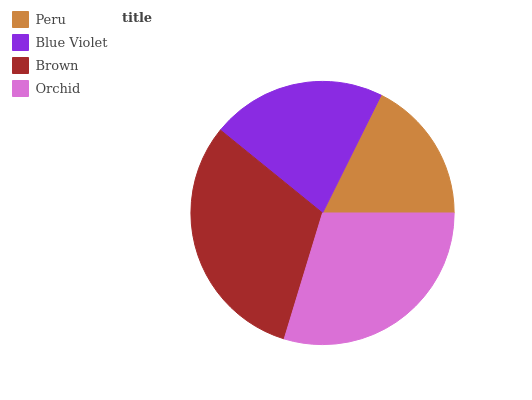Is Peru the minimum?
Answer yes or no. Yes. Is Brown the maximum?
Answer yes or no. Yes. Is Blue Violet the minimum?
Answer yes or no. No. Is Blue Violet the maximum?
Answer yes or no. No. Is Blue Violet greater than Peru?
Answer yes or no. Yes. Is Peru less than Blue Violet?
Answer yes or no. Yes. Is Peru greater than Blue Violet?
Answer yes or no. No. Is Blue Violet less than Peru?
Answer yes or no. No. Is Orchid the high median?
Answer yes or no. Yes. Is Blue Violet the low median?
Answer yes or no. Yes. Is Brown the high median?
Answer yes or no. No. Is Orchid the low median?
Answer yes or no. No. 